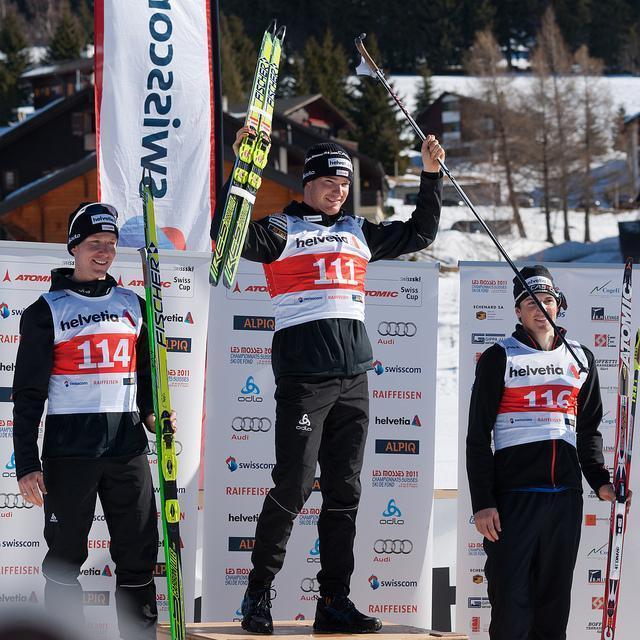How many people can be seen?
Give a very brief answer. 3. How many ski are there?
Give a very brief answer. 3. How many zebras are there?
Give a very brief answer. 0. 